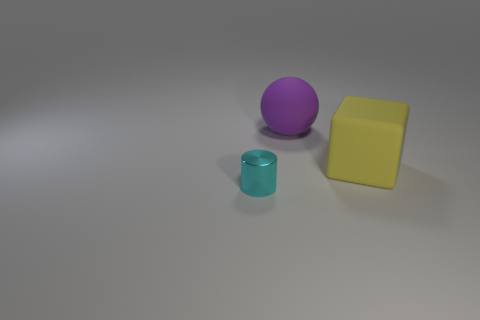Add 3 purple balls. How many objects exist? 6 Subtract all balls. How many objects are left? 2 Add 3 small cyan rubber cylinders. How many small cyan rubber cylinders exist? 3 Subtract 1 purple balls. How many objects are left? 2 Subtract all big purple matte objects. Subtract all cyan shiny objects. How many objects are left? 1 Add 2 large yellow matte things. How many large yellow matte things are left? 3 